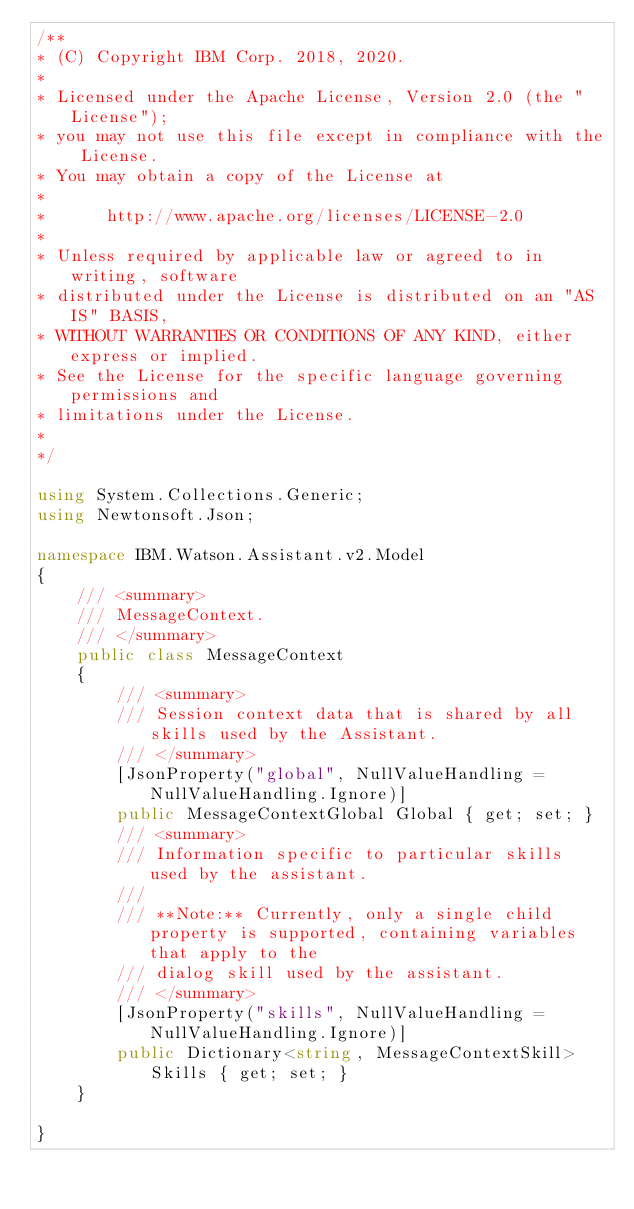Convert code to text. <code><loc_0><loc_0><loc_500><loc_500><_C#_>/**
* (C) Copyright IBM Corp. 2018, 2020.
*
* Licensed under the Apache License, Version 2.0 (the "License");
* you may not use this file except in compliance with the License.
* You may obtain a copy of the License at
*
*      http://www.apache.org/licenses/LICENSE-2.0
*
* Unless required by applicable law or agreed to in writing, software
* distributed under the License is distributed on an "AS IS" BASIS,
* WITHOUT WARRANTIES OR CONDITIONS OF ANY KIND, either express or implied.
* See the License for the specific language governing permissions and
* limitations under the License.
*
*/

using System.Collections.Generic;
using Newtonsoft.Json;

namespace IBM.Watson.Assistant.v2.Model
{
    /// <summary>
    /// MessageContext.
    /// </summary>
    public class MessageContext
    {
        /// <summary>
        /// Session context data that is shared by all skills used by the Assistant.
        /// </summary>
        [JsonProperty("global", NullValueHandling = NullValueHandling.Ignore)]
        public MessageContextGlobal Global { get; set; }
        /// <summary>
        /// Information specific to particular skills used by the assistant.
        ///
        /// **Note:** Currently, only a single child property is supported, containing variables that apply to the
        /// dialog skill used by the assistant.
        /// </summary>
        [JsonProperty("skills", NullValueHandling = NullValueHandling.Ignore)]
        public Dictionary<string, MessageContextSkill> Skills { get; set; }
    }

}
</code> 